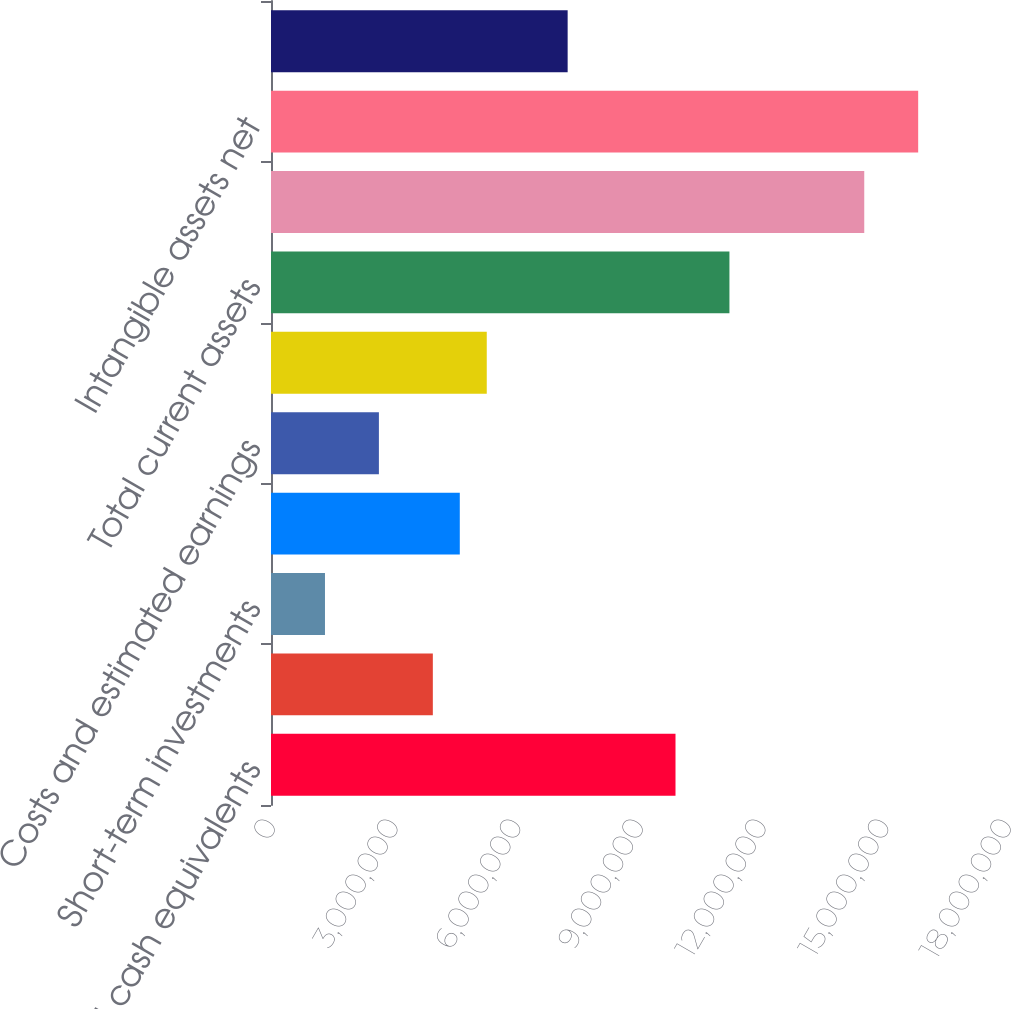Convert chart. <chart><loc_0><loc_0><loc_500><loc_500><bar_chart><fcel>Cash and cash equivalents<fcel>Restricted cash<fcel>Short-term investments<fcel>Accounts receivable net of<fcel>Costs and estimated earnings<fcel>Prepaid and other current<fcel>Total current assets<fcel>Property and equipment net<fcel>Intangible assets net<fcel>Deferred financing fees net<nl><fcel>9.89279e+06<fcel>3.95788e+06<fcel>1.32014e+06<fcel>4.61731e+06<fcel>2.63901e+06<fcel>5.27675e+06<fcel>1.12117e+07<fcel>1.45088e+07<fcel>1.58277e+07<fcel>7.25505e+06<nl></chart> 